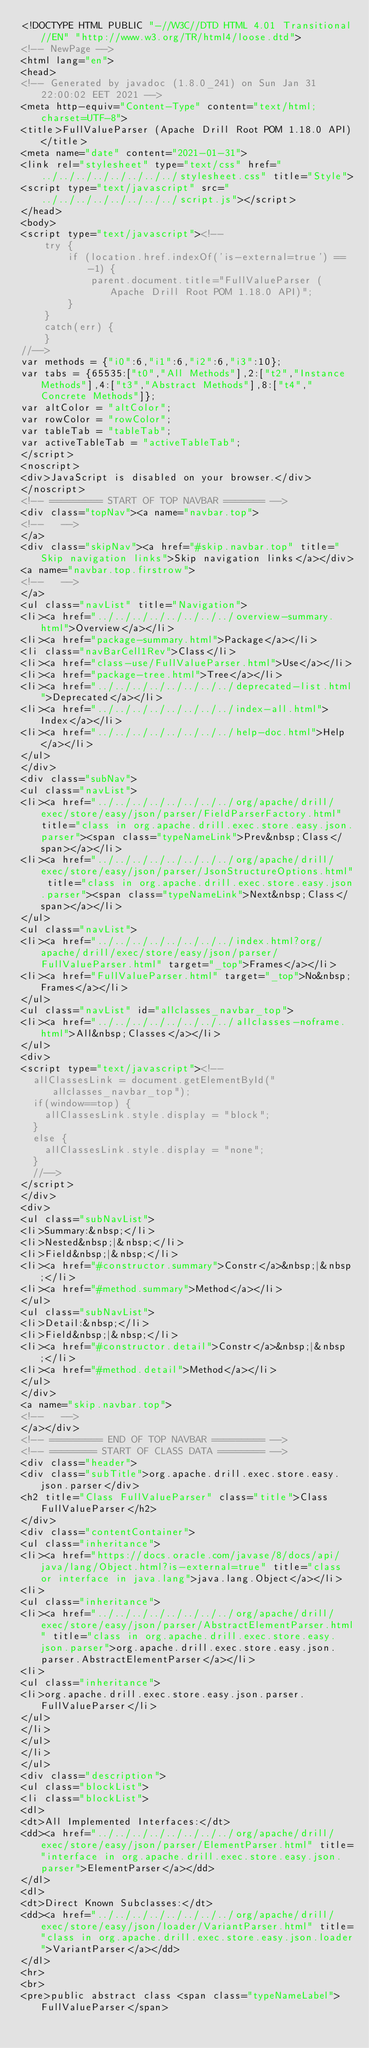Convert code to text. <code><loc_0><loc_0><loc_500><loc_500><_HTML_><!DOCTYPE HTML PUBLIC "-//W3C//DTD HTML 4.01 Transitional//EN" "http://www.w3.org/TR/html4/loose.dtd">
<!-- NewPage -->
<html lang="en">
<head>
<!-- Generated by javadoc (1.8.0_241) on Sun Jan 31 22:00:02 EET 2021 -->
<meta http-equiv="Content-Type" content="text/html; charset=UTF-8">
<title>FullValueParser (Apache Drill Root POM 1.18.0 API)</title>
<meta name="date" content="2021-01-31">
<link rel="stylesheet" type="text/css" href="../../../../../../../../stylesheet.css" title="Style">
<script type="text/javascript" src="../../../../../../../../script.js"></script>
</head>
<body>
<script type="text/javascript"><!--
    try {
        if (location.href.indexOf('is-external=true') == -1) {
            parent.document.title="FullValueParser (Apache Drill Root POM 1.18.0 API)";
        }
    }
    catch(err) {
    }
//-->
var methods = {"i0":6,"i1":6,"i2":6,"i3":10};
var tabs = {65535:["t0","All Methods"],2:["t2","Instance Methods"],4:["t3","Abstract Methods"],8:["t4","Concrete Methods"]};
var altColor = "altColor";
var rowColor = "rowColor";
var tableTab = "tableTab";
var activeTableTab = "activeTableTab";
</script>
<noscript>
<div>JavaScript is disabled on your browser.</div>
</noscript>
<!-- ========= START OF TOP NAVBAR ======= -->
<div class="topNav"><a name="navbar.top">
<!--   -->
</a>
<div class="skipNav"><a href="#skip.navbar.top" title="Skip navigation links">Skip navigation links</a></div>
<a name="navbar.top.firstrow">
<!--   -->
</a>
<ul class="navList" title="Navigation">
<li><a href="../../../../../../../../overview-summary.html">Overview</a></li>
<li><a href="package-summary.html">Package</a></li>
<li class="navBarCell1Rev">Class</li>
<li><a href="class-use/FullValueParser.html">Use</a></li>
<li><a href="package-tree.html">Tree</a></li>
<li><a href="../../../../../../../../deprecated-list.html">Deprecated</a></li>
<li><a href="../../../../../../../../index-all.html">Index</a></li>
<li><a href="../../../../../../../../help-doc.html">Help</a></li>
</ul>
</div>
<div class="subNav">
<ul class="navList">
<li><a href="../../../../../../../../org/apache/drill/exec/store/easy/json/parser/FieldParserFactory.html" title="class in org.apache.drill.exec.store.easy.json.parser"><span class="typeNameLink">Prev&nbsp;Class</span></a></li>
<li><a href="../../../../../../../../org/apache/drill/exec/store/easy/json/parser/JsonStructureOptions.html" title="class in org.apache.drill.exec.store.easy.json.parser"><span class="typeNameLink">Next&nbsp;Class</span></a></li>
</ul>
<ul class="navList">
<li><a href="../../../../../../../../index.html?org/apache/drill/exec/store/easy/json/parser/FullValueParser.html" target="_top">Frames</a></li>
<li><a href="FullValueParser.html" target="_top">No&nbsp;Frames</a></li>
</ul>
<ul class="navList" id="allclasses_navbar_top">
<li><a href="../../../../../../../../allclasses-noframe.html">All&nbsp;Classes</a></li>
</ul>
<div>
<script type="text/javascript"><!--
  allClassesLink = document.getElementById("allclasses_navbar_top");
  if(window==top) {
    allClassesLink.style.display = "block";
  }
  else {
    allClassesLink.style.display = "none";
  }
  //-->
</script>
</div>
<div>
<ul class="subNavList">
<li>Summary:&nbsp;</li>
<li>Nested&nbsp;|&nbsp;</li>
<li>Field&nbsp;|&nbsp;</li>
<li><a href="#constructor.summary">Constr</a>&nbsp;|&nbsp;</li>
<li><a href="#method.summary">Method</a></li>
</ul>
<ul class="subNavList">
<li>Detail:&nbsp;</li>
<li>Field&nbsp;|&nbsp;</li>
<li><a href="#constructor.detail">Constr</a>&nbsp;|&nbsp;</li>
<li><a href="#method.detail">Method</a></li>
</ul>
</div>
<a name="skip.navbar.top">
<!--   -->
</a></div>
<!-- ========= END OF TOP NAVBAR ========= -->
<!-- ======== START OF CLASS DATA ======== -->
<div class="header">
<div class="subTitle">org.apache.drill.exec.store.easy.json.parser</div>
<h2 title="Class FullValueParser" class="title">Class FullValueParser</h2>
</div>
<div class="contentContainer">
<ul class="inheritance">
<li><a href="https://docs.oracle.com/javase/8/docs/api/java/lang/Object.html?is-external=true" title="class or interface in java.lang">java.lang.Object</a></li>
<li>
<ul class="inheritance">
<li><a href="../../../../../../../../org/apache/drill/exec/store/easy/json/parser/AbstractElementParser.html" title="class in org.apache.drill.exec.store.easy.json.parser">org.apache.drill.exec.store.easy.json.parser.AbstractElementParser</a></li>
<li>
<ul class="inheritance">
<li>org.apache.drill.exec.store.easy.json.parser.FullValueParser</li>
</ul>
</li>
</ul>
</li>
</ul>
<div class="description">
<ul class="blockList">
<li class="blockList">
<dl>
<dt>All Implemented Interfaces:</dt>
<dd><a href="../../../../../../../../org/apache/drill/exec/store/easy/json/parser/ElementParser.html" title="interface in org.apache.drill.exec.store.easy.json.parser">ElementParser</a></dd>
</dl>
<dl>
<dt>Direct Known Subclasses:</dt>
<dd><a href="../../../../../../../../org/apache/drill/exec/store/easy/json/loader/VariantParser.html" title="class in org.apache.drill.exec.store.easy.json.loader">VariantParser</a></dd>
</dl>
<hr>
<br>
<pre>public abstract class <span class="typeNameLabel">FullValueParser</span></code> 